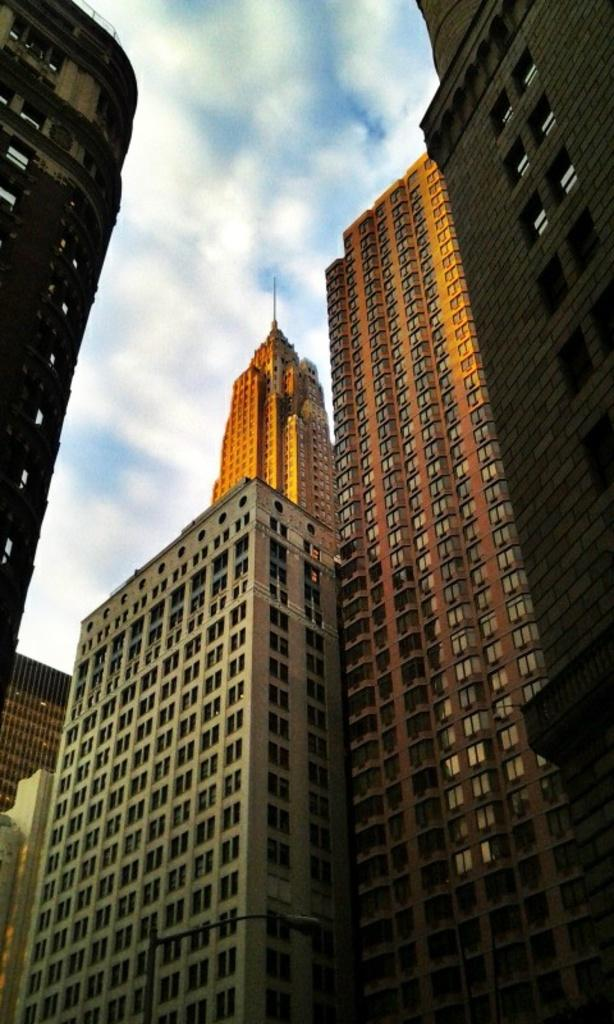What type of structures can be seen in the image? There are buildings in the image. What object is standing upright in the image? A pole is visible in the image. What type of lighting fixture is present in the image? A street light is present in the image. What can be seen in the background of the image? There are clouds and the sky visible in the background of the image. What type of leaf is being used as a thrill ride in the image? There is no leaf or thrill ride present in the image. What type of metal is used to construct the buildings in the image? The provided facts do not specify the type of metal used to construct the buildings in the image. 